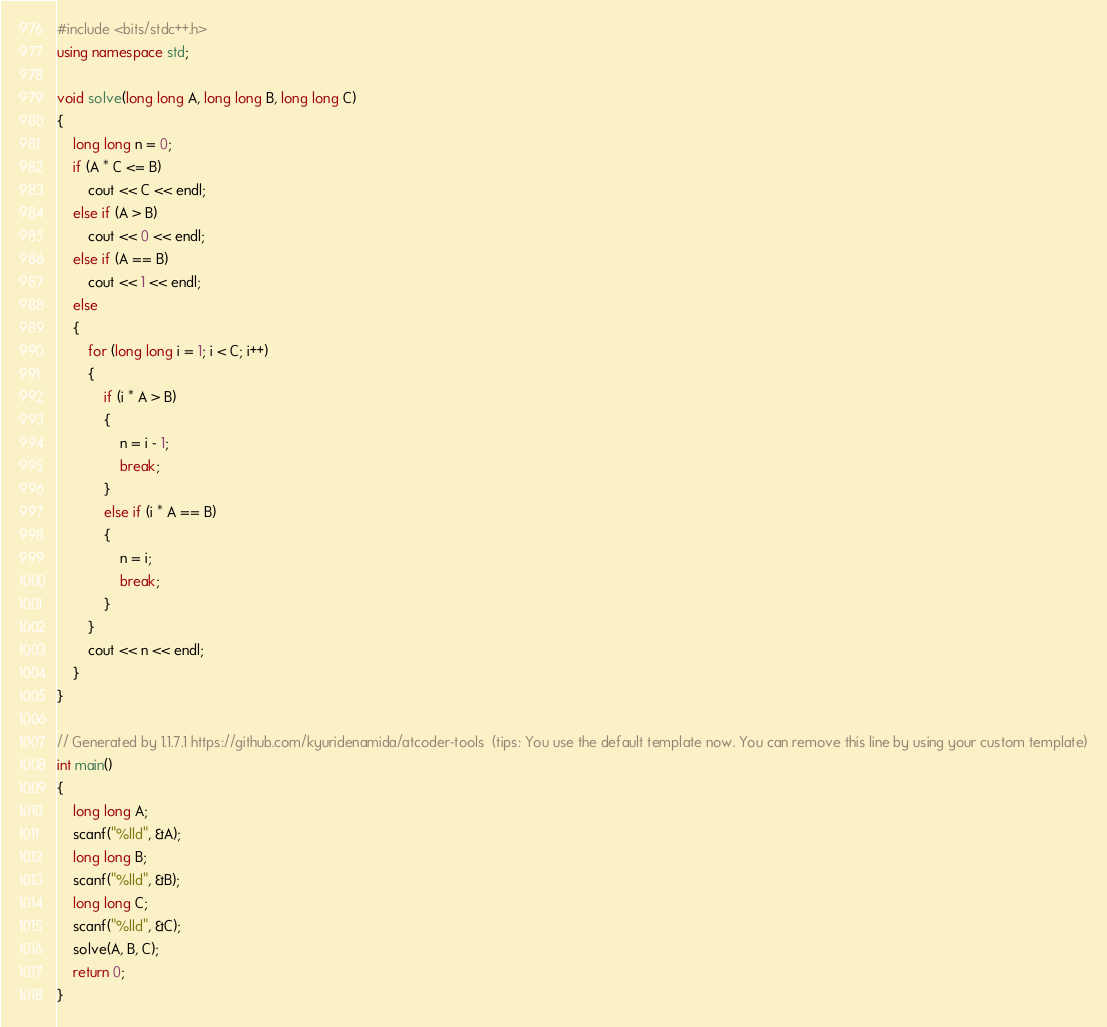Convert code to text. <code><loc_0><loc_0><loc_500><loc_500><_C++_>#include <bits/stdc++.h>
using namespace std;

void solve(long long A, long long B, long long C)
{
    long long n = 0;
    if (A * C <= B)
        cout << C << endl;
    else if (A > B)
        cout << 0 << endl;
    else if (A == B)
        cout << 1 << endl;
    else
    {
        for (long long i = 1; i < C; i++)
        {
            if (i * A > B)
            {
                n = i - 1;
                break;
            }
            else if (i * A == B)
            {
                n = i;
                break;
            }
        }
        cout << n << endl;
    }
}

// Generated by 1.1.7.1 https://github.com/kyuridenamida/atcoder-tools  (tips: You use the default template now. You can remove this line by using your custom template)
int main()
{
    long long A;
    scanf("%lld", &A);
    long long B;
    scanf("%lld", &B);
    long long C;
    scanf("%lld", &C);
    solve(A, B, C);
    return 0;
}
</code> 